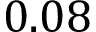<formula> <loc_0><loc_0><loc_500><loc_500>0 . 0 8</formula> 